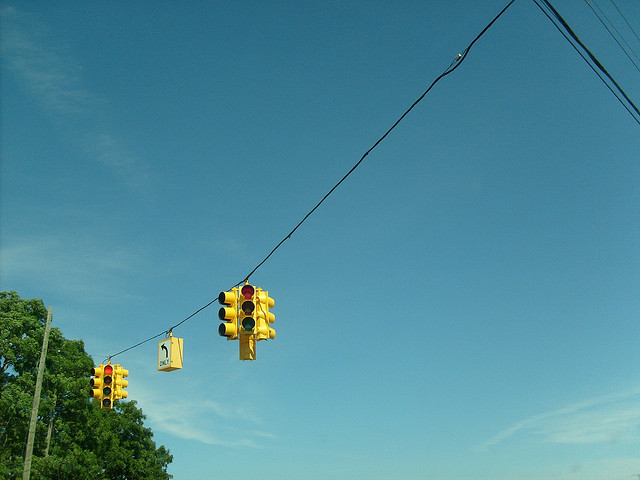What time of day does this photo seem to depict, and why is that important for traffic management? The photo appears to be taken during a clear day, likely in the morning given the brightness and shadow directions. Managing traffic lights during peak times, like mornings, is crucial for avoiding bottlenecks and ensuring a steady flow of school and work commuter traffic. Does weather affect how traffic lights operate? Absolutely, weather conditions can influence traffic light functioning. For instance, extreme weather can lead to power outages affecting the lights, or heavy rain can impair sensor effectiveness, requiring manual traffic management or adjustments in light timing to maintain safety. 